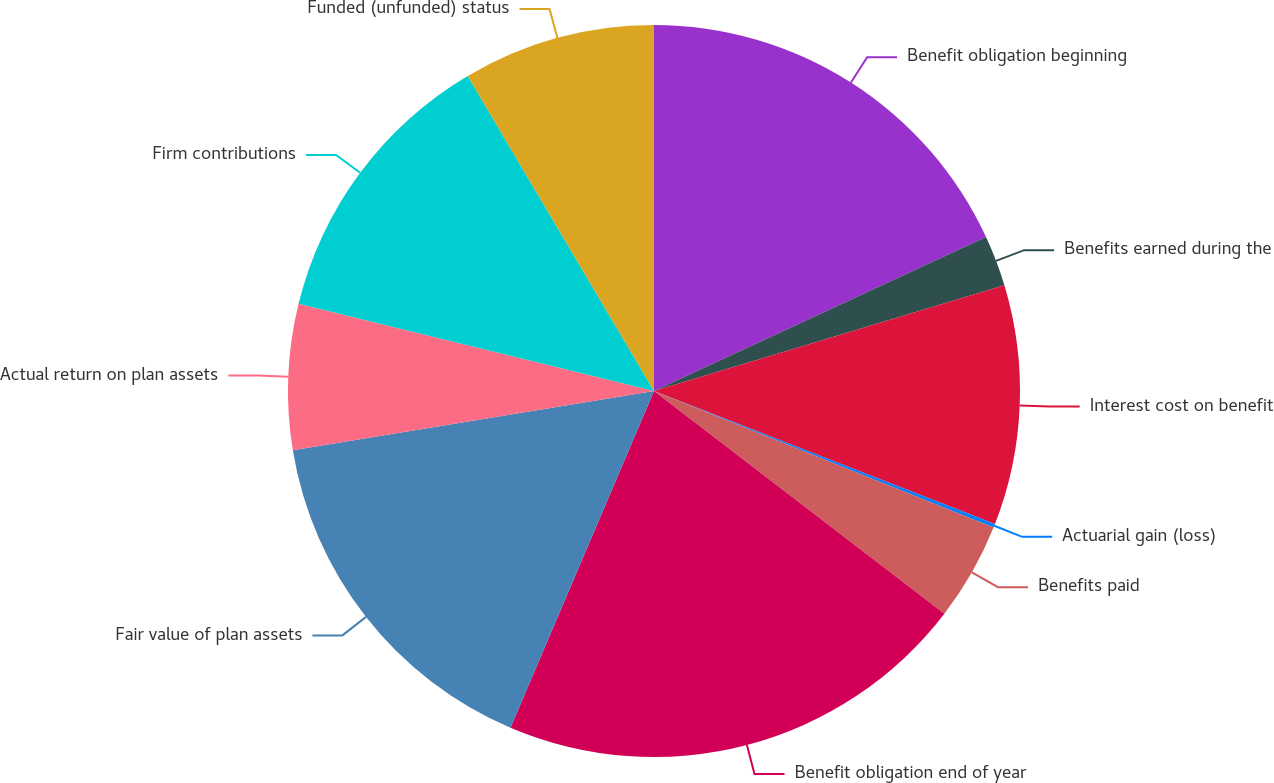Convert chart. <chart><loc_0><loc_0><loc_500><loc_500><pie_chart><fcel>Benefit obligation beginning<fcel>Benefits earned during the<fcel>Interest cost on benefit<fcel>Actuarial gain (loss)<fcel>Benefits paid<fcel>Benefit obligation end of year<fcel>Fair value of plan assets<fcel>Actual return on plan assets<fcel>Firm contributions<fcel>Funded (unfunded) status<nl><fcel>18.09%<fcel>2.25%<fcel>10.58%<fcel>0.17%<fcel>4.33%<fcel>21.0%<fcel>16.0%<fcel>6.42%<fcel>12.67%<fcel>8.5%<nl></chart> 